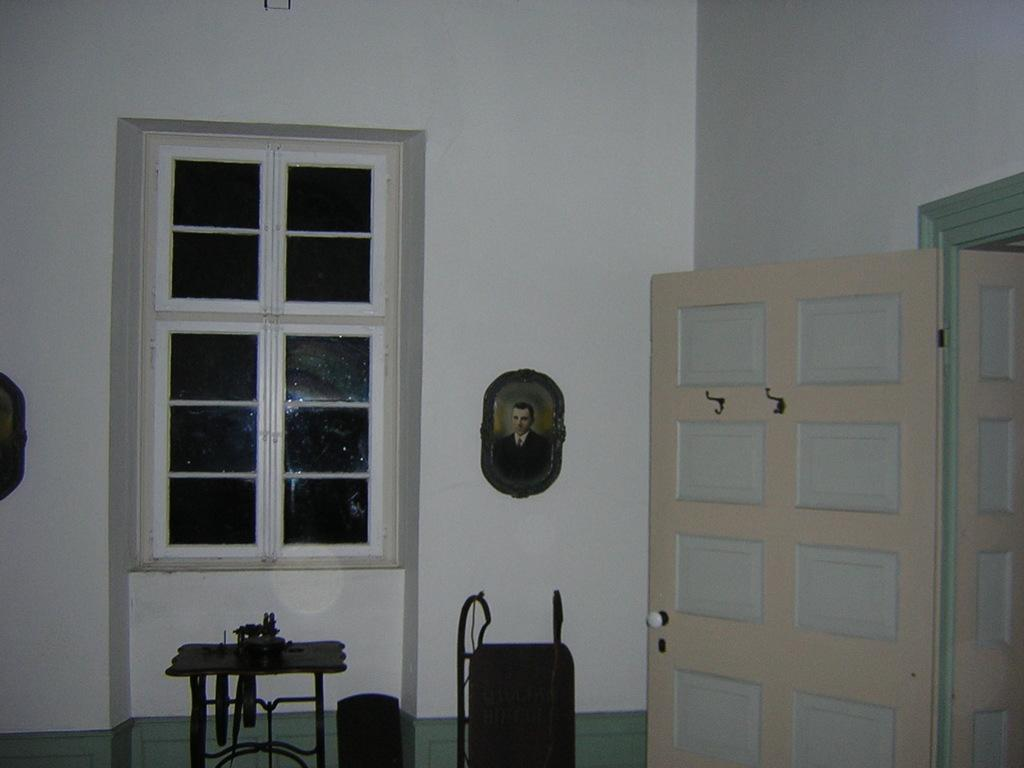What type of openings can be seen in the image? There are doors and windows in the image. What is hanging on the wall in the image? There is a photo frame on the wall. What is located in front of the photo frame? There is a table in front of the photo frame. What can be found on top of the table? There are objects on top of the table. Can you see any monkeys or snakes in the image? No, there are no monkeys or snakes present in the image. 